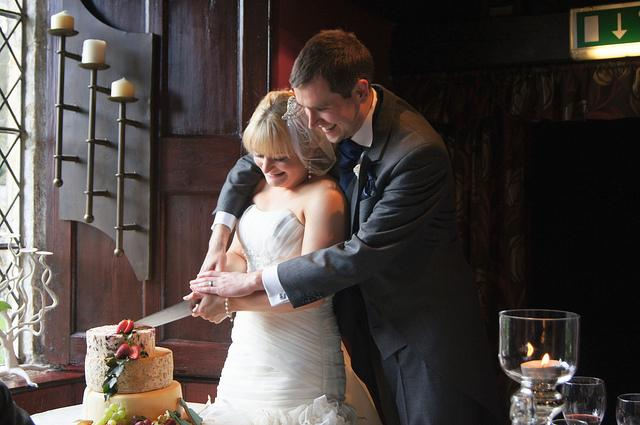What did the pair here recently exchange? Please explain your reasoning. rings. Bride and groom cut a cake like this at their wedding and rings are exchanged when they say their vows 